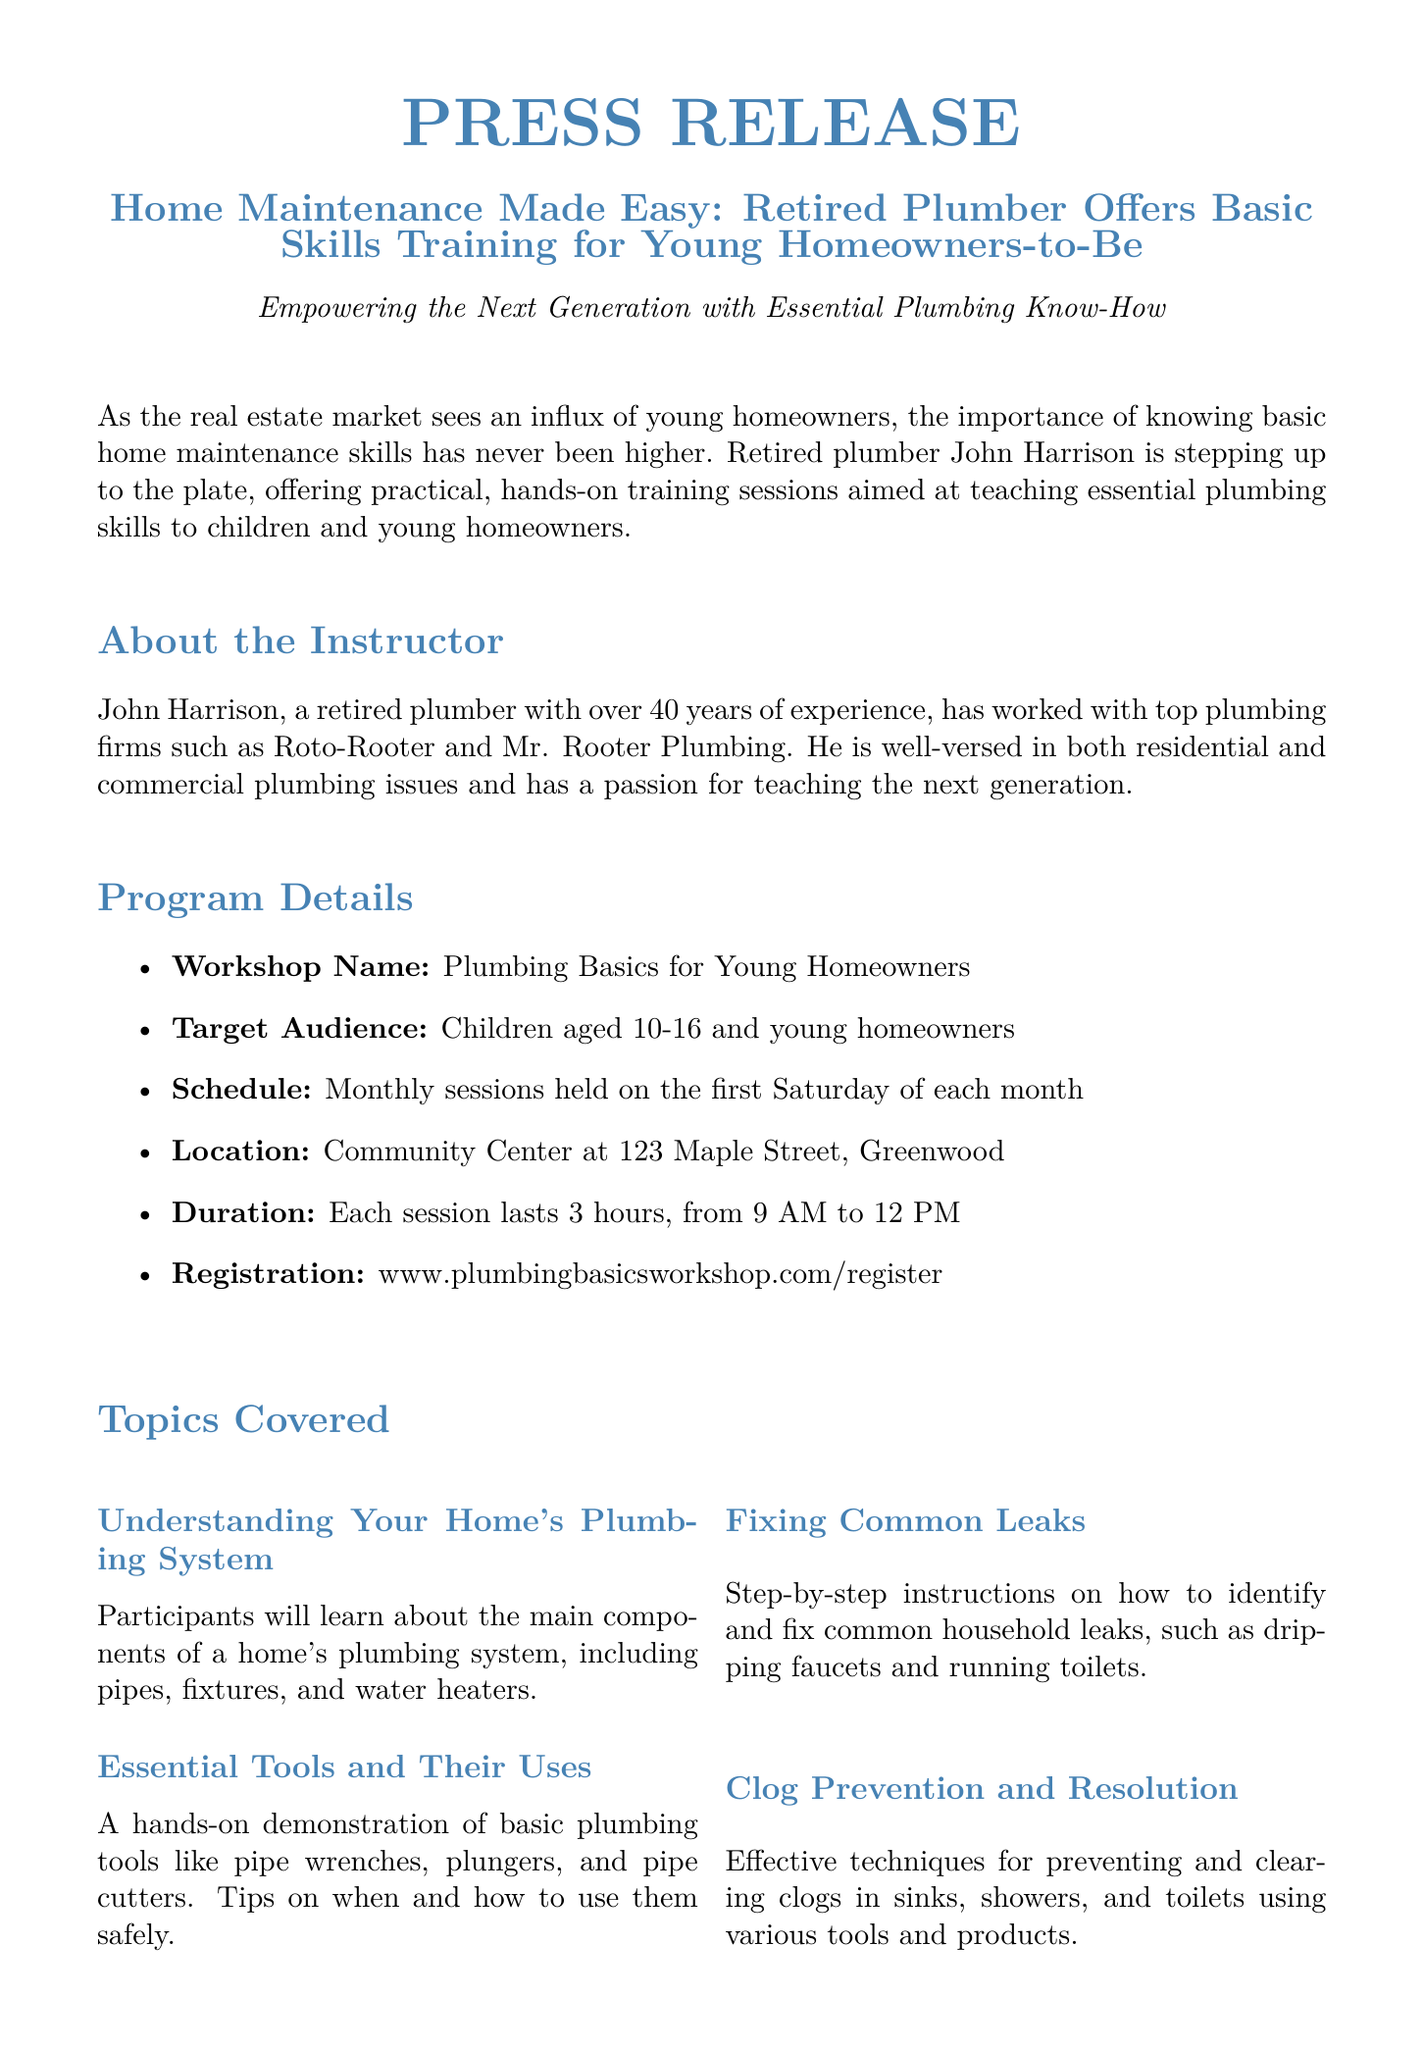What is the name of the workshop? The workshop is titled "Plumbing Basics for Young Homeowners".
Answer: Plumbing Basics for Young Homeowners Who is the instructor? The instructor mentioned is John Harrison, a retired plumber.
Answer: John Harrison What is the age range of the target audience? The target audience is children aged 10-16 and young homeowners.
Answer: 10-16 How long does each session last? Each session lasts for 3 hours, from 9 AM to 12 PM.
Answer: 3 hours What is the location of the training sessions? The training sessions are held at the Community Center at 123 Maple Street, Greenwood.
Answer: Community Center at 123 Maple Street, Greenwood Why is this workshop important for young homeowners? The workshop empowers young homeowners with essential plumbing know-how.
Answer: Essential plumbing know-how What day of the month are sessions held? Sessions are held on the first Saturday of each month.
Answer: First Saturday What is the website for registration? The website for registration is www.plumbingbasicsworkshop.com/register.
Answer: www.plumbingbasicsworkshop.com/register How many years of experience does John Harrison have? John Harrison has over 40 years of experience in plumbing.
Answer: Over 40 years 